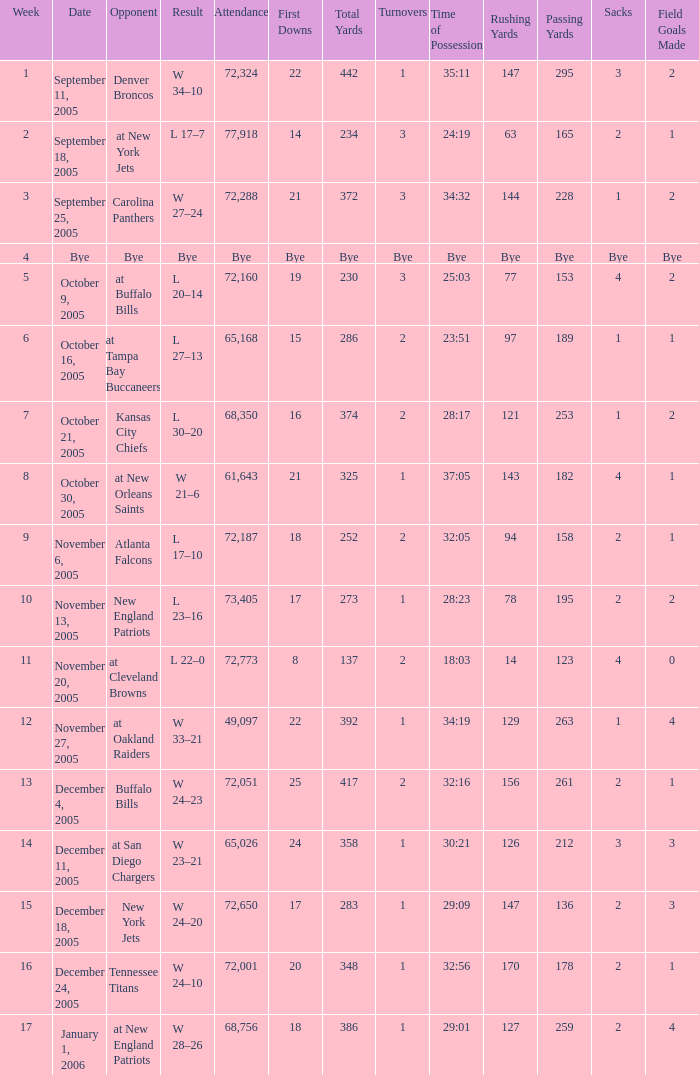Who was the Opponent on November 27, 2005? At oakland raiders. 